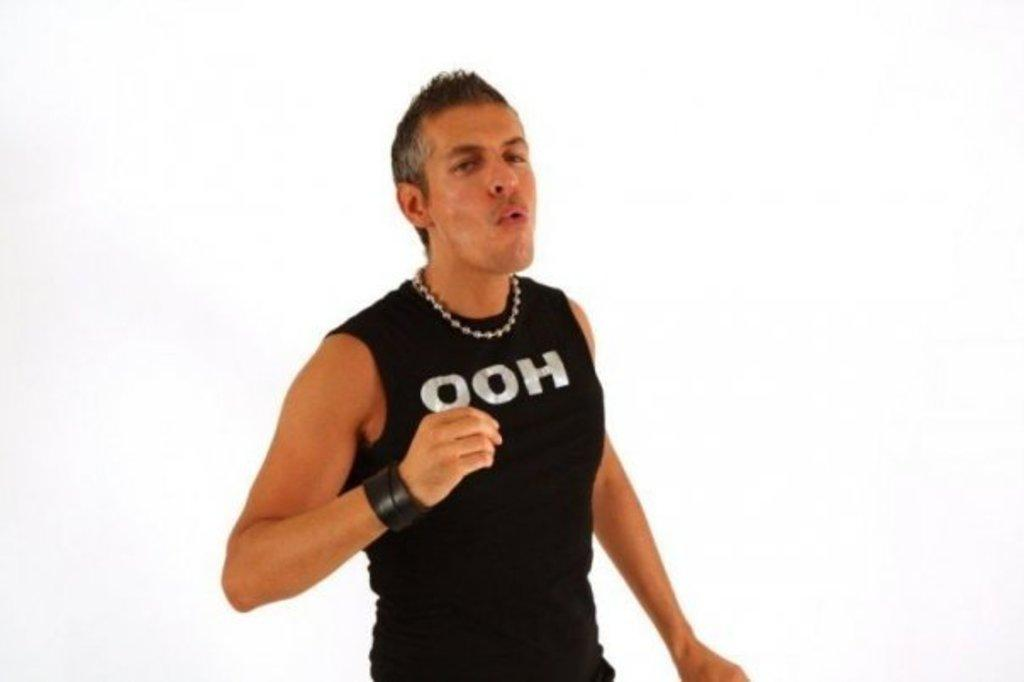Provide a one-sentence caption for the provided image. Man with the words ooh wrote on his black tank top shirt. 